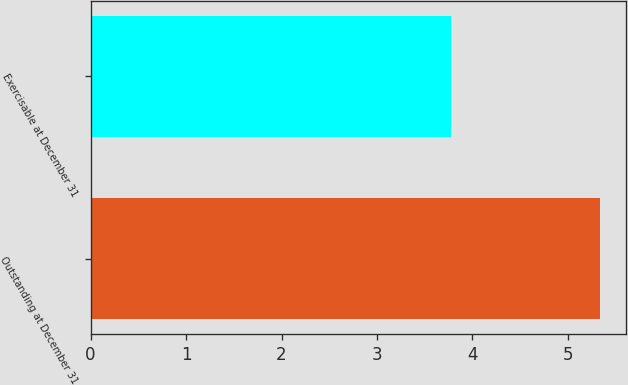Convert chart to OTSL. <chart><loc_0><loc_0><loc_500><loc_500><bar_chart><fcel>Outstanding at December 31<fcel>Exercisable at December 31<nl><fcel>5.34<fcel>3.77<nl></chart> 